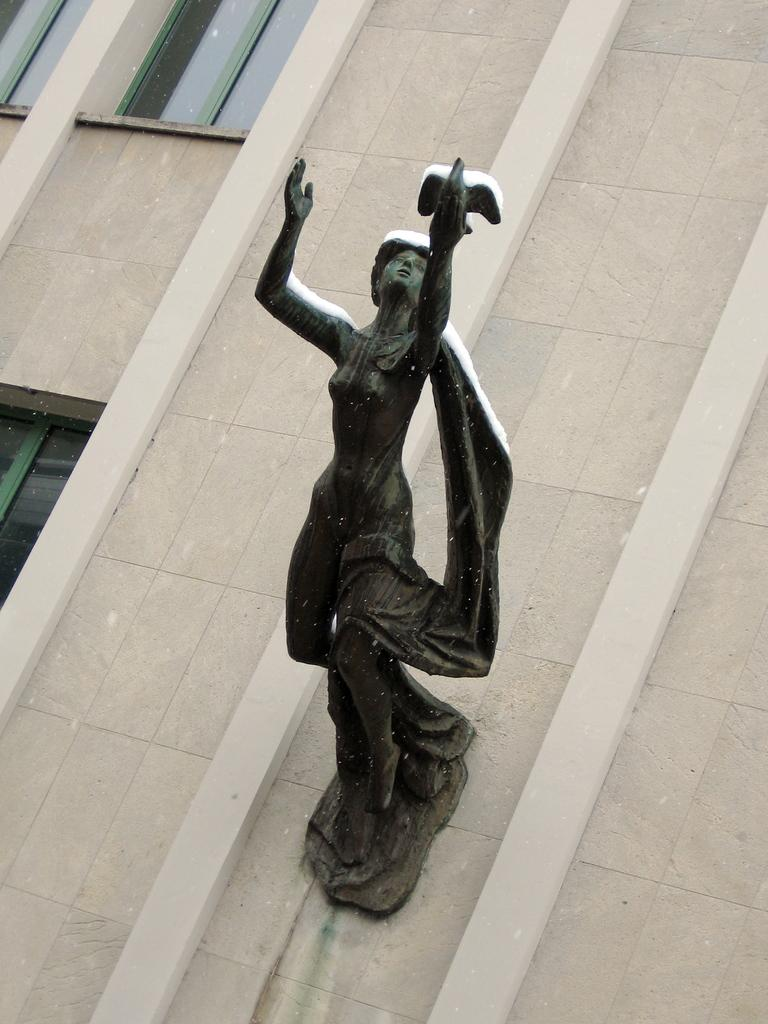What is the main subject in the center of the image? There is a sculpture in the center of the image. Where is the sculpture located? The sculpture is on a building. What else can be seen on the building in the image? There are windows visible in the image. What type of juice is being served in the image? There is no juice present in the image; it features a sculpture on a building with visible windows. 